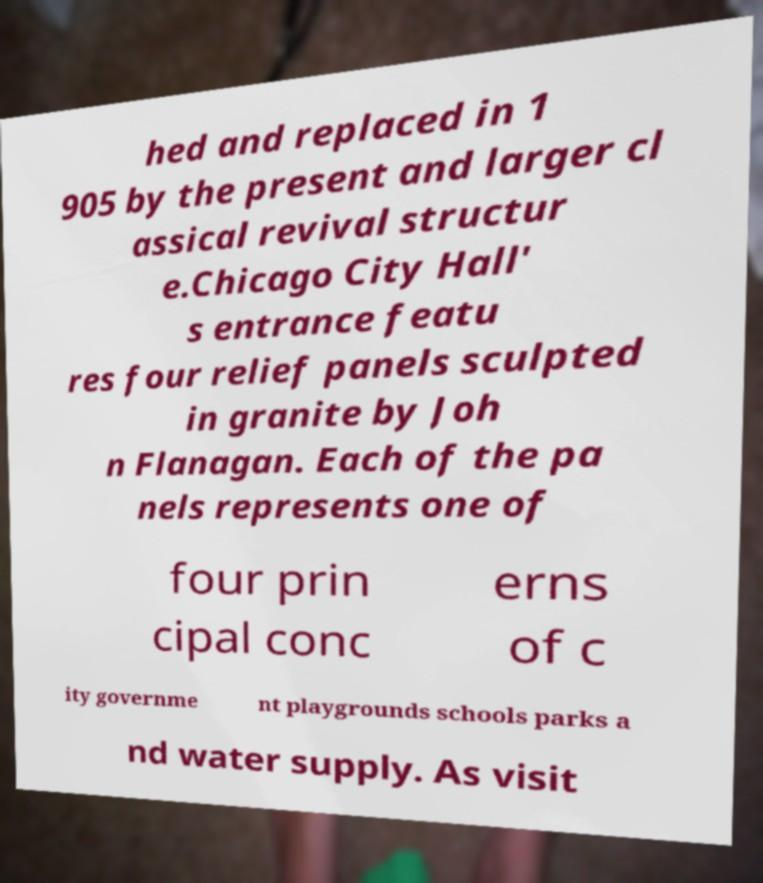Please identify and transcribe the text found in this image. hed and replaced in 1 905 by the present and larger cl assical revival structur e.Chicago City Hall' s entrance featu res four relief panels sculpted in granite by Joh n Flanagan. Each of the pa nels represents one of four prin cipal conc erns of c ity governme nt playgrounds schools parks a nd water supply. As visit 